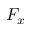<formula> <loc_0><loc_0><loc_500><loc_500>F _ { x }</formula> 